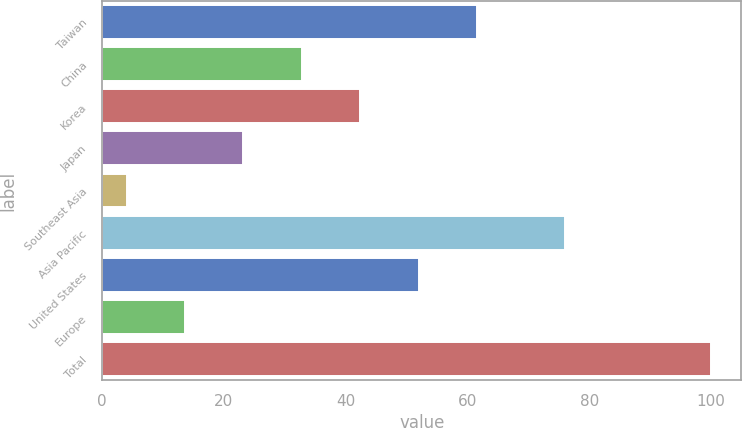Convert chart. <chart><loc_0><loc_0><loc_500><loc_500><bar_chart><fcel>Taiwan<fcel>China<fcel>Korea<fcel>Japan<fcel>Southeast Asia<fcel>Asia Pacific<fcel>United States<fcel>Europe<fcel>Total<nl><fcel>61.6<fcel>32.8<fcel>42.4<fcel>23.2<fcel>4<fcel>76<fcel>52<fcel>13.6<fcel>100<nl></chart> 